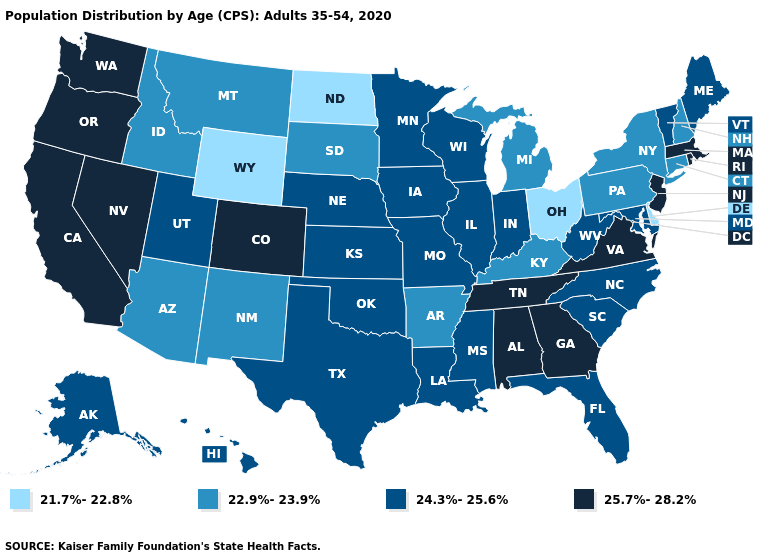Does the map have missing data?
Be succinct. No. Name the states that have a value in the range 24.3%-25.6%?
Keep it brief. Alaska, Florida, Hawaii, Illinois, Indiana, Iowa, Kansas, Louisiana, Maine, Maryland, Minnesota, Mississippi, Missouri, Nebraska, North Carolina, Oklahoma, South Carolina, Texas, Utah, Vermont, West Virginia, Wisconsin. Name the states that have a value in the range 25.7%-28.2%?
Answer briefly. Alabama, California, Colorado, Georgia, Massachusetts, Nevada, New Jersey, Oregon, Rhode Island, Tennessee, Virginia, Washington. Does Alabama have a higher value than Washington?
Be succinct. No. Name the states that have a value in the range 21.7%-22.8%?
Answer briefly. Delaware, North Dakota, Ohio, Wyoming. Which states hav the highest value in the South?
Quick response, please. Alabama, Georgia, Tennessee, Virginia. What is the value of Massachusetts?
Write a very short answer. 25.7%-28.2%. Among the states that border Minnesota , does Iowa have the lowest value?
Short answer required. No. Among the states that border Michigan , does Indiana have the lowest value?
Give a very brief answer. No. Among the states that border Indiana , does Illinois have the highest value?
Answer briefly. Yes. What is the highest value in the South ?
Write a very short answer. 25.7%-28.2%. Does Florida have the lowest value in the USA?
Answer briefly. No. Among the states that border Montana , which have the lowest value?
Keep it brief. North Dakota, Wyoming. Which states have the lowest value in the South?
Give a very brief answer. Delaware. 